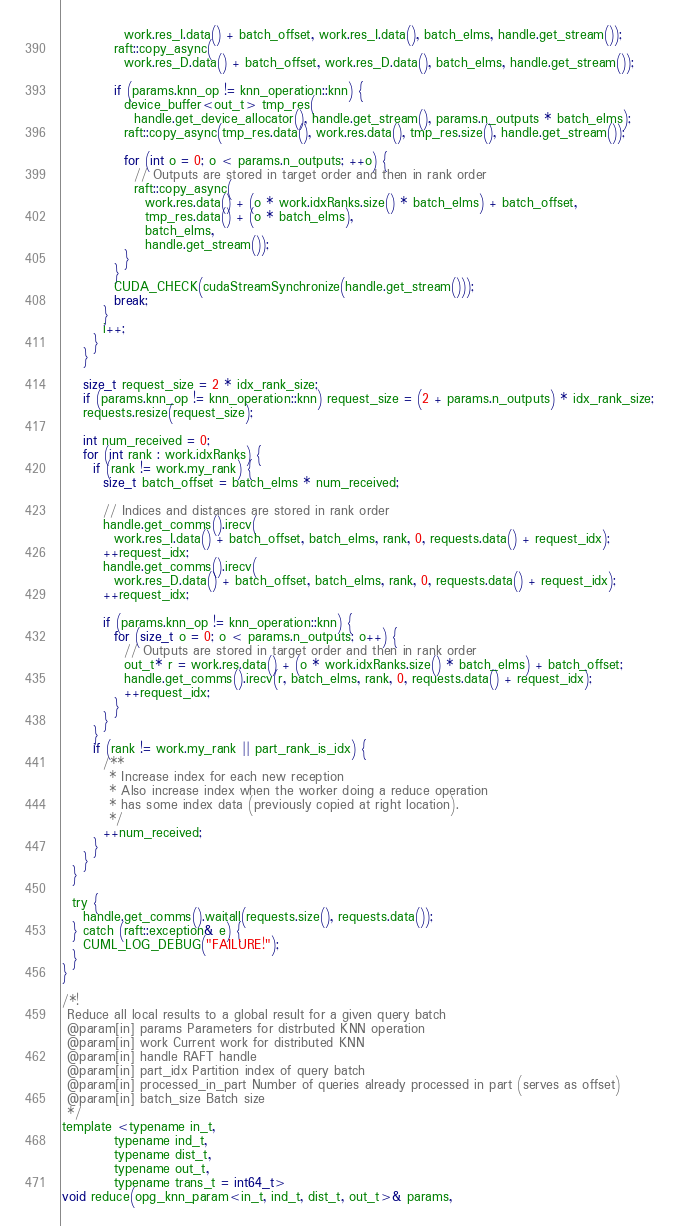<code> <loc_0><loc_0><loc_500><loc_500><_Cuda_>            work.res_I.data() + batch_offset, work.res_I.data(), batch_elms, handle.get_stream());
          raft::copy_async(
            work.res_D.data() + batch_offset, work.res_D.data(), batch_elms, handle.get_stream());

          if (params.knn_op != knn_operation::knn) {
            device_buffer<out_t> tmp_res(
              handle.get_device_allocator(), handle.get_stream(), params.n_outputs * batch_elms);
            raft::copy_async(tmp_res.data(), work.res.data(), tmp_res.size(), handle.get_stream());

            for (int o = 0; o < params.n_outputs; ++o) {
              // Outputs are stored in target order and then in rank order
              raft::copy_async(
                work.res.data() + (o * work.idxRanks.size() * batch_elms) + batch_offset,
                tmp_res.data() + (o * batch_elms),
                batch_elms,
                handle.get_stream());
            }
          }
          CUDA_CHECK(cudaStreamSynchronize(handle.get_stream()));
          break;
        }
        i++;
      }
    }

    size_t request_size = 2 * idx_rank_size;
    if (params.knn_op != knn_operation::knn) request_size = (2 + params.n_outputs) * idx_rank_size;
    requests.resize(request_size);

    int num_received = 0;
    for (int rank : work.idxRanks) {
      if (rank != work.my_rank) {
        size_t batch_offset = batch_elms * num_received;

        // Indices and distances are stored in rank order
        handle.get_comms().irecv(
          work.res_I.data() + batch_offset, batch_elms, rank, 0, requests.data() + request_idx);
        ++request_idx;
        handle.get_comms().irecv(
          work.res_D.data() + batch_offset, batch_elms, rank, 0, requests.data() + request_idx);
        ++request_idx;

        if (params.knn_op != knn_operation::knn) {
          for (size_t o = 0; o < params.n_outputs; o++) {
            // Outputs are stored in target order and then in rank order
            out_t* r = work.res.data() + (o * work.idxRanks.size() * batch_elms) + batch_offset;
            handle.get_comms().irecv(r, batch_elms, rank, 0, requests.data() + request_idx);
            ++request_idx;
          }
        }
      }
      if (rank != work.my_rank || part_rank_is_idx) {
        /**
         * Increase index for each new reception
         * Also increase index when the worker doing a reduce operation
         * has some index data (previously copied at right location).
         */
        ++num_received;
      }
    }
  }

  try {
    handle.get_comms().waitall(requests.size(), requests.data());
  } catch (raft::exception& e) {
    CUML_LOG_DEBUG("FAILURE!");
  }
}

/*!
 Reduce all local results to a global result for a given query batch
 @param[in] params Parameters for distrbuted KNN operation
 @param[in] work Current work for distributed KNN
 @param[in] handle RAFT handle
 @param[in] part_idx Partition index of query batch
 @param[in] processed_in_part Number of queries already processed in part (serves as offset)
 @param[in] batch_size Batch size
 */
template <typename in_t,
          typename ind_t,
          typename dist_t,
          typename out_t,
          typename trans_t = int64_t>
void reduce(opg_knn_param<in_t, ind_t, dist_t, out_t>& params,</code> 